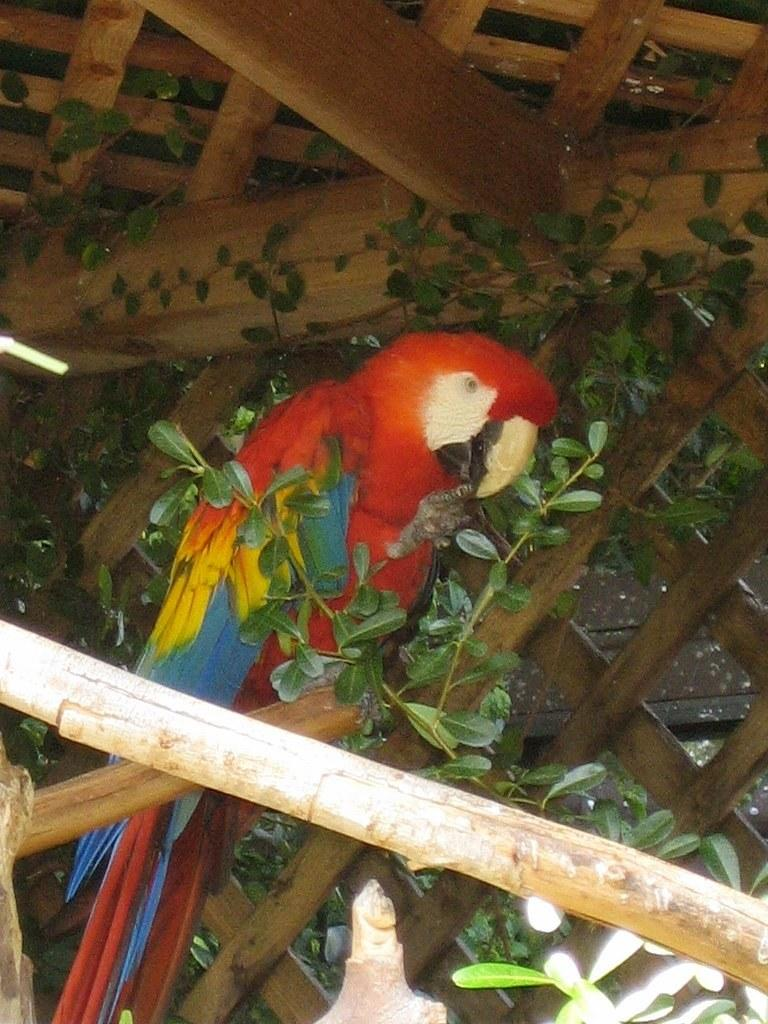What is the main subject in the center of the image? There is a bird in the center of the image. What type of vegetation can be seen in the image? There are leaves visible in the image. What type of material is used for the fence in the image? There is a wooden fence in the image. What object is made of wood and visible in the image? There is a wooden stick in the image. What type of health issues are being discussed at the nighttime meeting in the image? There is no meeting or health issues present in the image; it features a bird, leaves, a wooden fence, and a wooden stick. 